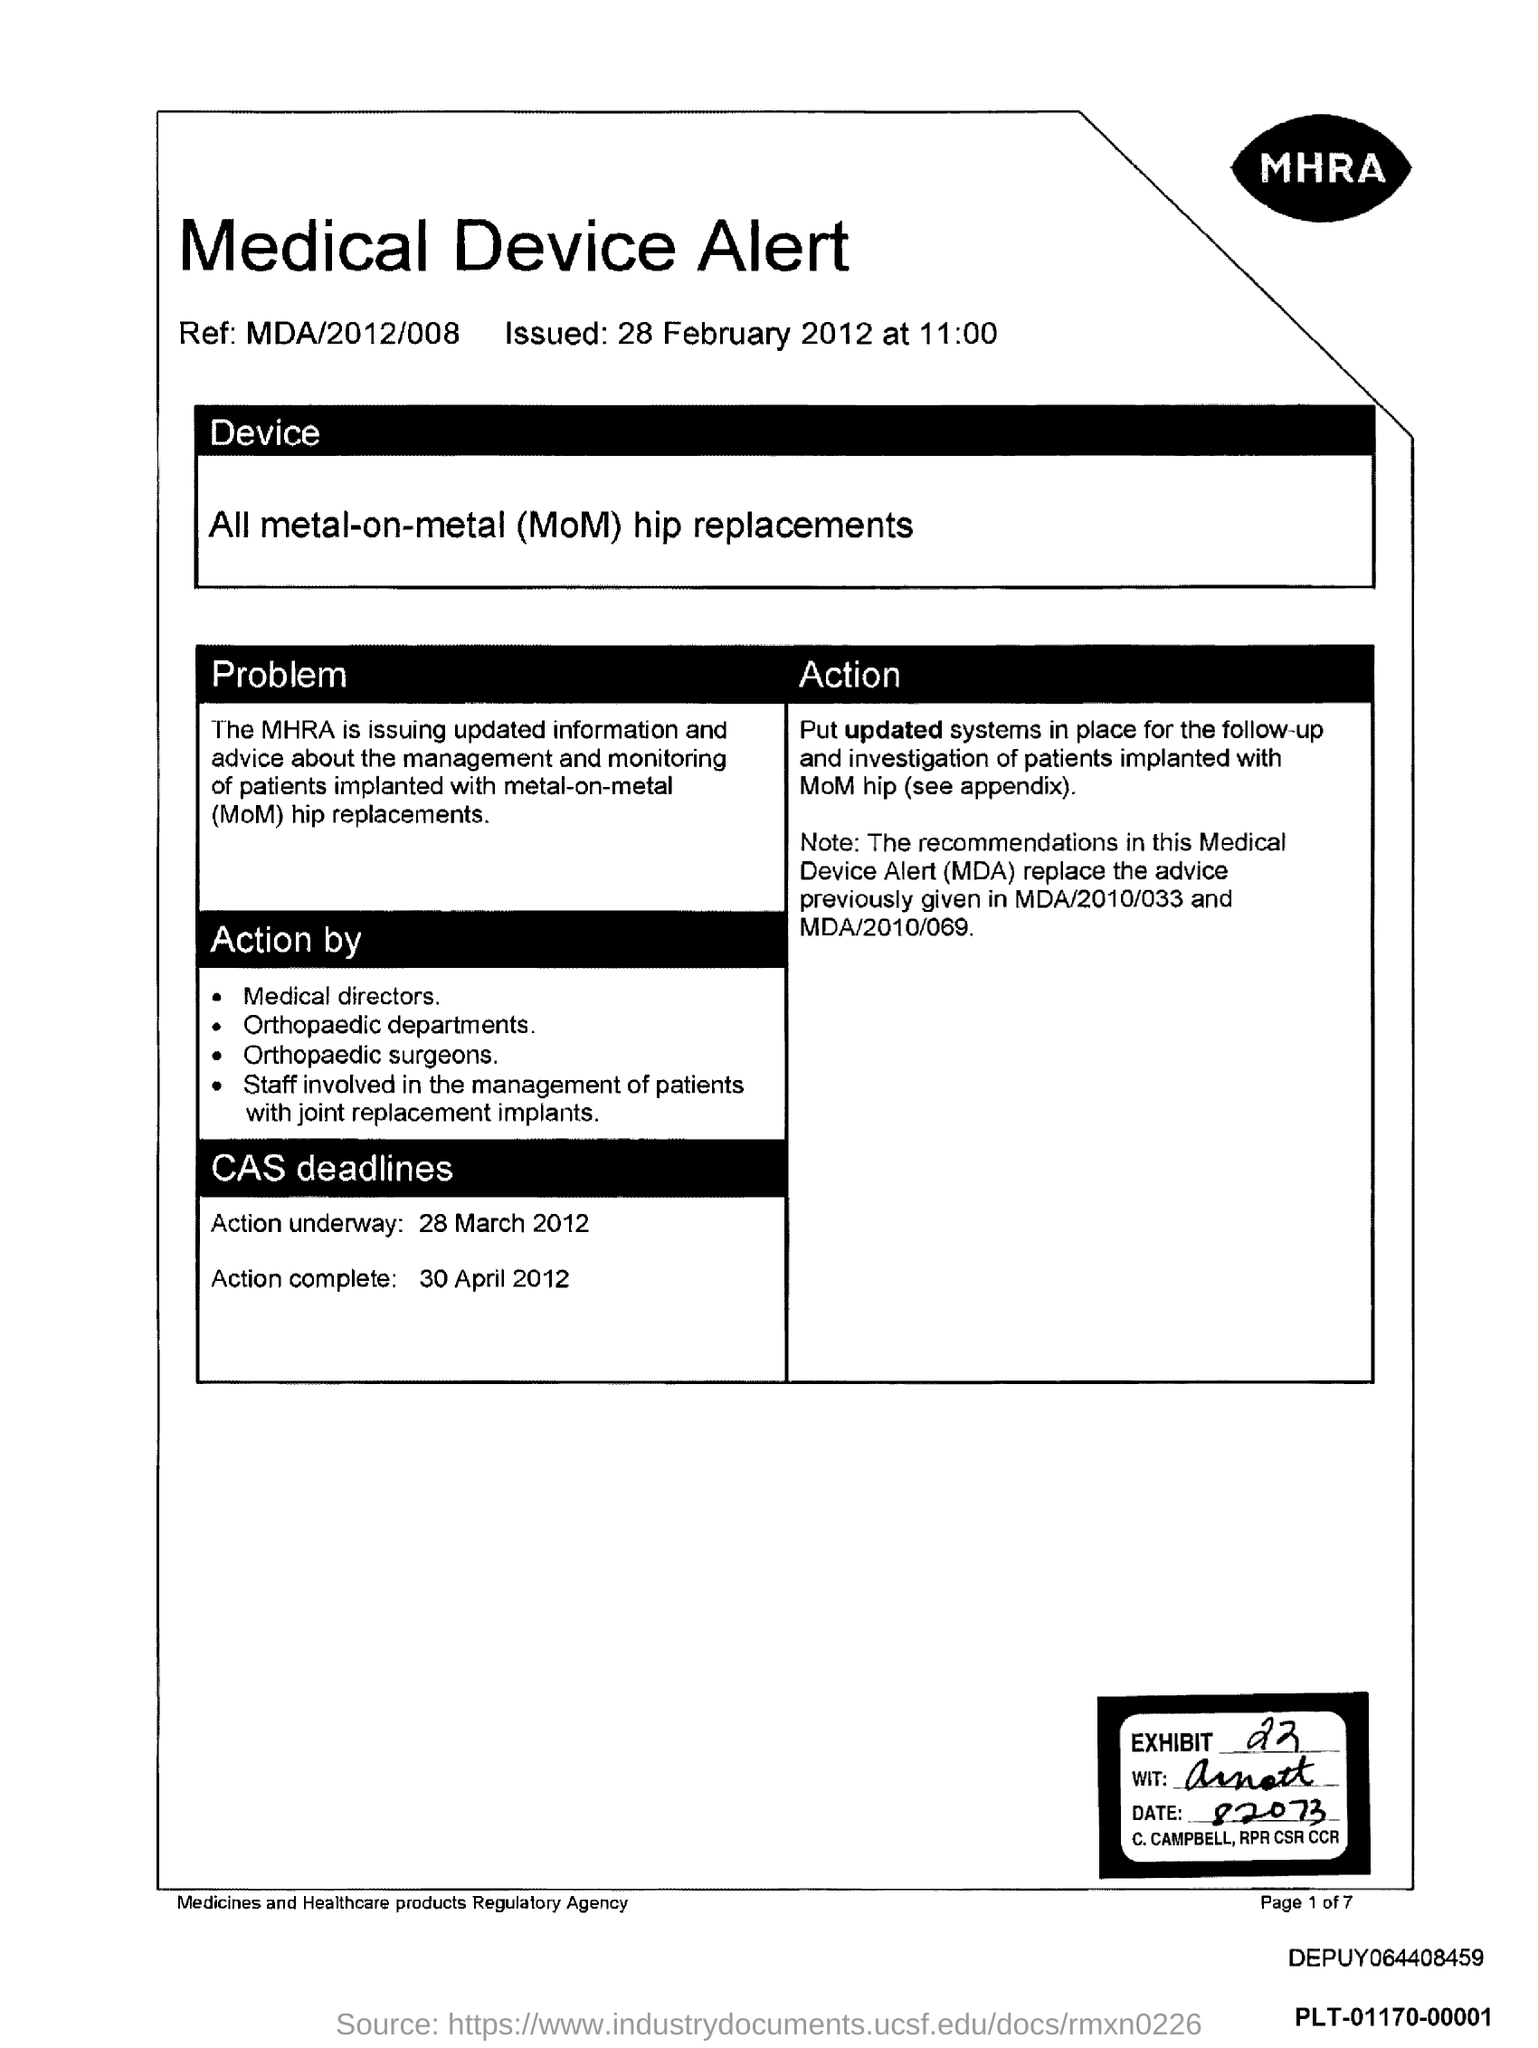What is the Reference code?
Give a very brief answer. MDA/2012/008. What is the date of issue?
Your answer should be very brief. 28 February 2012. What is the time of issue?
Provide a short and direct response. 11:00. What is the action complete date?
Ensure brevity in your answer.  30 April 2012. Which is the device?
Offer a terse response. All metal-on-metal (MoM) hip replacements. Which agency is it?
Make the answer very short. Medicines and healthcare products regulatory agency. Who is the first in the list of action taken by?
Give a very brief answer. Medical directors. What is the exhibit number?
Give a very brief answer. 22. 